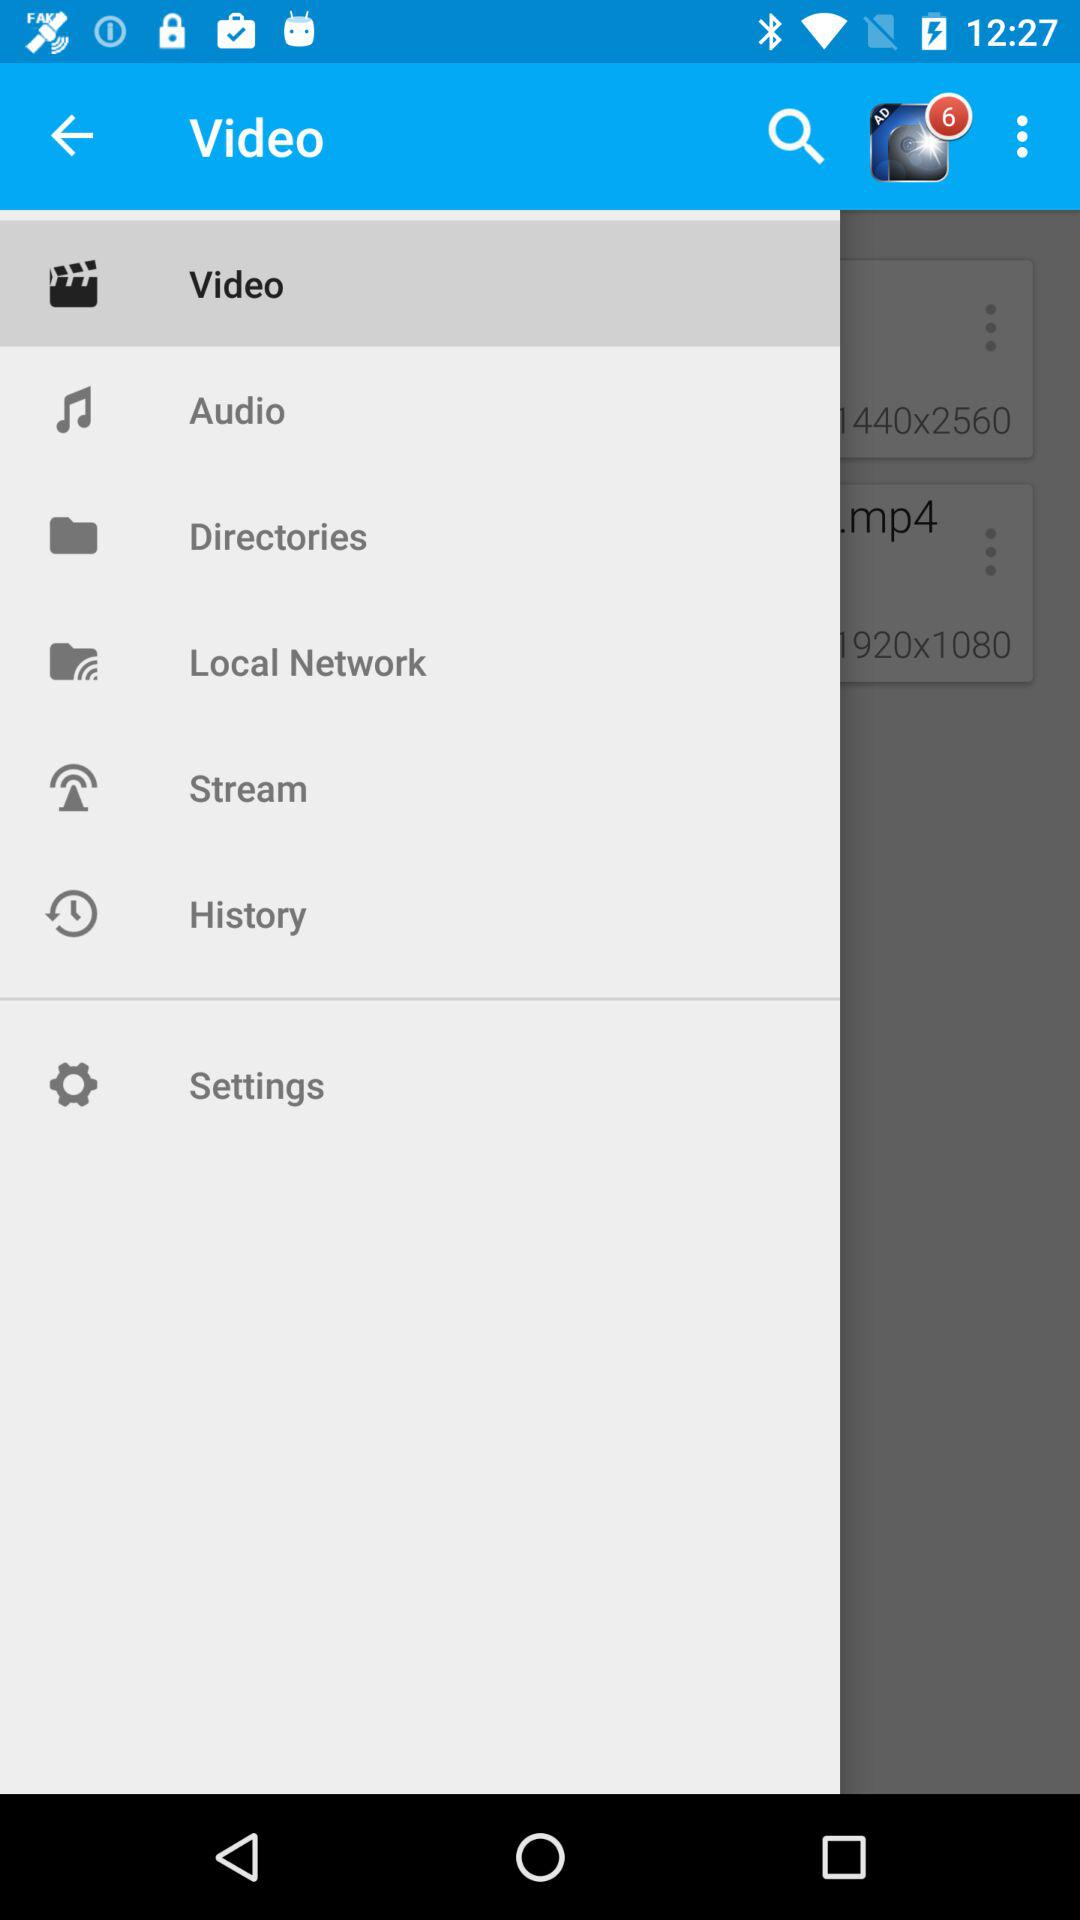Which item is selected? The selected item is "Video". 